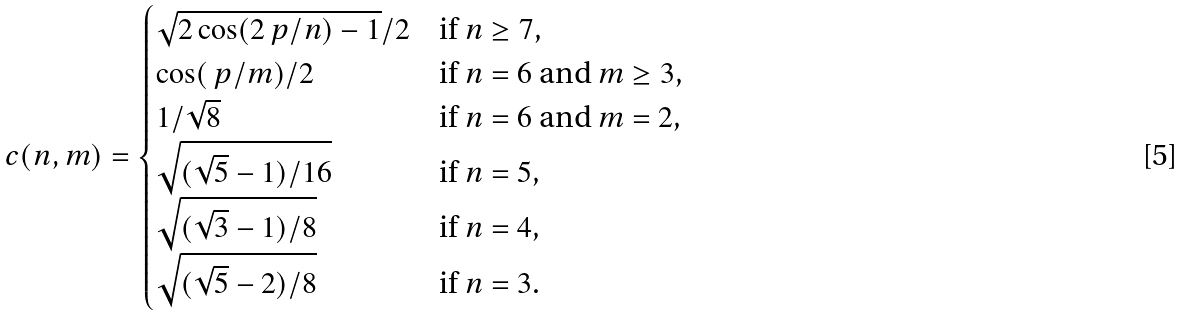Convert formula to latex. <formula><loc_0><loc_0><loc_500><loc_500>c ( n , m ) = \begin{cases} \sqrt { 2 \cos ( 2 \ p / n ) - 1 } / 2 & \text {if $n \geq 7$,} \\ \cos ( \ p / m ) / 2 & \text {if $n=6$ and $m \geq 3$,} \\ 1 / \sqrt { 8 } & \text {if $n=6$ and $m=2$,} \\ \sqrt { ( \sqrt { 5 } - 1 ) / 1 6 } & \text {if $n=5$,} \\ \sqrt { ( \sqrt { 3 } - 1 ) / 8 } & \text {if $n=4$,} \\ \sqrt { ( \sqrt { 5 } - 2 ) / 8 } & \text {if $n=3$.} \\ \end{cases}</formula> 